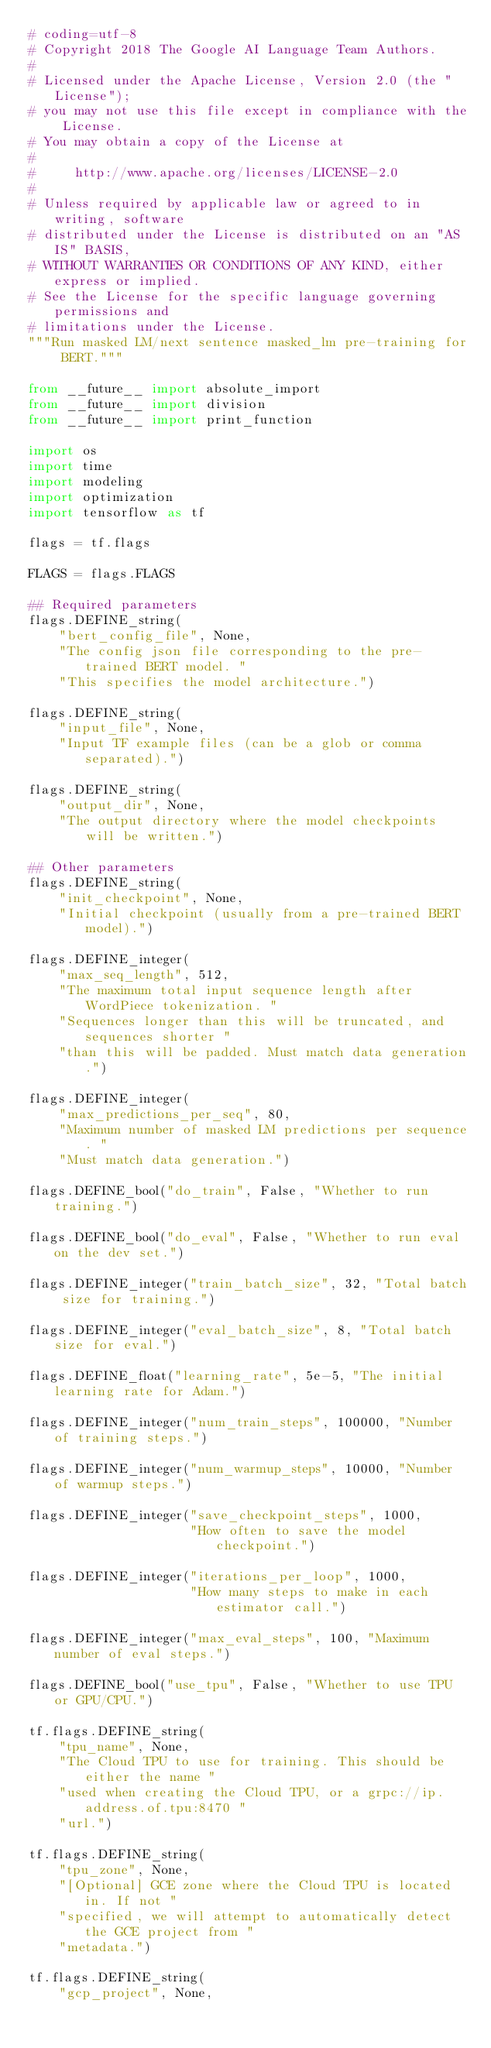Convert code to text. <code><loc_0><loc_0><loc_500><loc_500><_Python_># coding=utf-8
# Copyright 2018 The Google AI Language Team Authors.
#
# Licensed under the Apache License, Version 2.0 (the "License");
# you may not use this file except in compliance with the License.
# You may obtain a copy of the License at
#
#     http://www.apache.org/licenses/LICENSE-2.0
#
# Unless required by applicable law or agreed to in writing, software
# distributed under the License is distributed on an "AS IS" BASIS,
# WITHOUT WARRANTIES OR CONDITIONS OF ANY KIND, either express or implied.
# See the License for the specific language governing permissions and
# limitations under the License.
"""Run masked LM/next sentence masked_lm pre-training for BERT."""

from __future__ import absolute_import
from __future__ import division
from __future__ import print_function

import os
import time
import modeling
import optimization
import tensorflow as tf

flags = tf.flags

FLAGS = flags.FLAGS

## Required parameters
flags.DEFINE_string(
    "bert_config_file", None,
    "The config json file corresponding to the pre-trained BERT model. "
    "This specifies the model architecture.")

flags.DEFINE_string(
    "input_file", None,
    "Input TF example files (can be a glob or comma separated).")

flags.DEFINE_string(
    "output_dir", None,
    "The output directory where the model checkpoints will be written.")

## Other parameters
flags.DEFINE_string(
    "init_checkpoint", None,
    "Initial checkpoint (usually from a pre-trained BERT model).")

flags.DEFINE_integer(
    "max_seq_length", 512,
    "The maximum total input sequence length after WordPiece tokenization. "
    "Sequences longer than this will be truncated, and sequences shorter "
    "than this will be padded. Must match data generation.")

flags.DEFINE_integer(
    "max_predictions_per_seq", 80,
    "Maximum number of masked LM predictions per sequence. "
    "Must match data generation.")

flags.DEFINE_bool("do_train", False, "Whether to run training.")

flags.DEFINE_bool("do_eval", False, "Whether to run eval on the dev set.")

flags.DEFINE_integer("train_batch_size", 32, "Total batch size for training.")

flags.DEFINE_integer("eval_batch_size", 8, "Total batch size for eval.")

flags.DEFINE_float("learning_rate", 5e-5, "The initial learning rate for Adam.")

flags.DEFINE_integer("num_train_steps", 100000, "Number of training steps.")

flags.DEFINE_integer("num_warmup_steps", 10000, "Number of warmup steps.")

flags.DEFINE_integer("save_checkpoint_steps", 1000,
                     "How often to save the model checkpoint.")

flags.DEFINE_integer("iterations_per_loop", 1000,
                     "How many steps to make in each estimator call.")

flags.DEFINE_integer("max_eval_steps", 100, "Maximum number of eval steps.")

flags.DEFINE_bool("use_tpu", False, "Whether to use TPU or GPU/CPU.")

tf.flags.DEFINE_string(
    "tpu_name", None,
    "The Cloud TPU to use for training. This should be either the name "
    "used when creating the Cloud TPU, or a grpc://ip.address.of.tpu:8470 "
    "url.")

tf.flags.DEFINE_string(
    "tpu_zone", None,
    "[Optional] GCE zone where the Cloud TPU is located in. If not "
    "specified, we will attempt to automatically detect the GCE project from "
    "metadata.")

tf.flags.DEFINE_string(
    "gcp_project", None,</code> 